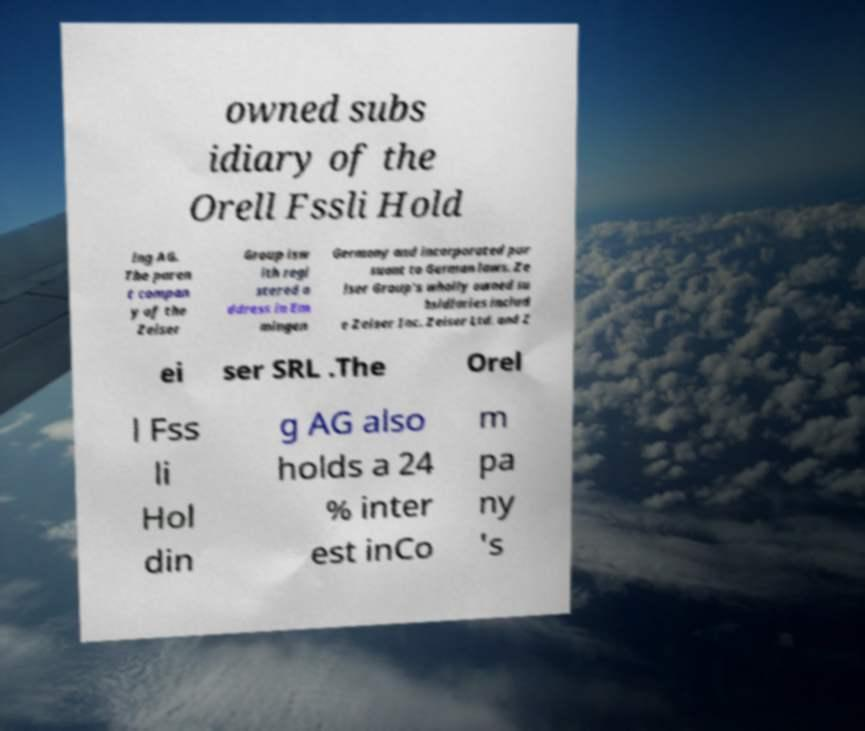Please read and relay the text visible in this image. What does it say? owned subs idiary of the Orell Fssli Hold ing AG. The paren t compan y of the Zeiser Group isw ith regi stered a ddress in Em mingen Germany and incorporated pur suant to German laws. Ze iser Group's wholly owned su bsidiaries includ e Zeiser Inc. Zeiser Ltd. and Z ei ser SRL .The Orel l Fss li Hol din g AG also holds a 24 % inter est inCo m pa ny 's 